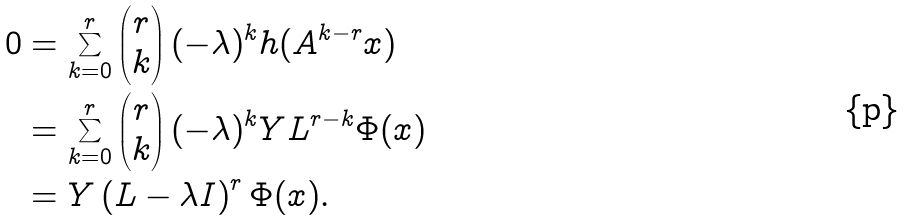Convert formula to latex. <formula><loc_0><loc_0><loc_500><loc_500>0 & = \sum _ { k = 0 } ^ { r } \begin{pmatrix} r \\ k \end{pmatrix} ( - \lambda ) ^ { k } h ( A ^ { k - r } x ) \\ & = \sum _ { k = 0 } ^ { r } \begin{pmatrix} r \\ k \end{pmatrix} ( - \lambda ) ^ { k } Y L ^ { r - k } \Phi ( x ) \\ & = Y \left ( L - \lambda I \right ) ^ { r } \Phi ( x ) .</formula> 